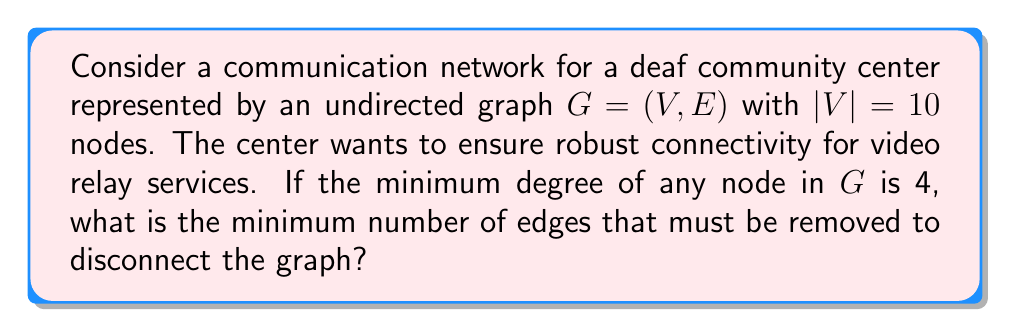Provide a solution to this math problem. To solve this problem, we'll use concepts from graph theory, particularly the relationship between vertex connectivity and minimum degree.

1) First, recall the theorem relating vertex connectivity $\kappa(G)$, edge connectivity $\lambda(G)$, and minimum degree $\delta(G)$:

   $$\kappa(G) \leq \lambda(G) \leq \delta(G)$$

2) We're given that the minimum degree $\delta(G) = 4$.

3) The question is asking about the minimum number of edges that must be removed to disconnect the graph, which is the definition of edge connectivity $\lambda(G)$.

4) From the theorem, we know that $\lambda(G) \leq \delta(G) = 4$.

5) However, we can't immediately conclude that $\lambda(G) = 4$. We need to consider the structure of the graph.

6) Given that this is a communication network designed for accessibility, it's reasonable to assume it's designed to be as robust as possible. In graph theory terms, this would mean it's likely to be optimally connected.

7) For an optimally connected graph, the vertex connectivity, edge connectivity, and minimum degree are all equal:

   $$\kappa(G) = \lambda(G) = \delta(G) = 4$$

8) Therefore, the minimum number of edges that must be removed to disconnect the graph is 4.

This result implies that the communication network is designed to maintain connectivity even if up to 3 connections fail, which is crucial for ensuring reliable video relay services for the deaf community.
Answer: 4 edges 